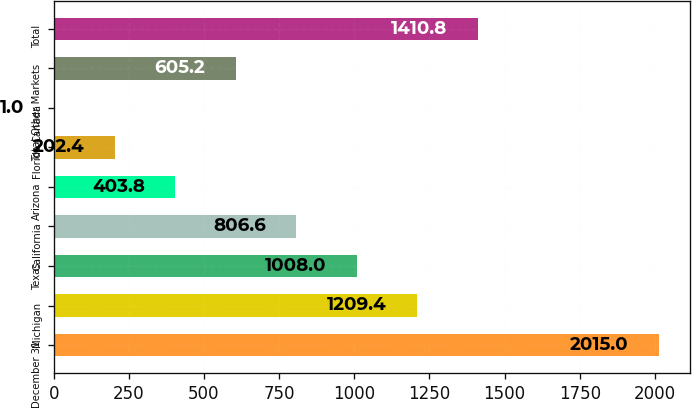Convert chart. <chart><loc_0><loc_0><loc_500><loc_500><bar_chart><fcel>December 31<fcel>Michigan<fcel>Texas<fcel>California<fcel>Arizona<fcel>Florida<fcel>Canada<fcel>Total Other Markets<fcel>Total<nl><fcel>2015<fcel>1209.4<fcel>1008<fcel>806.6<fcel>403.8<fcel>202.4<fcel>1<fcel>605.2<fcel>1410.8<nl></chart> 